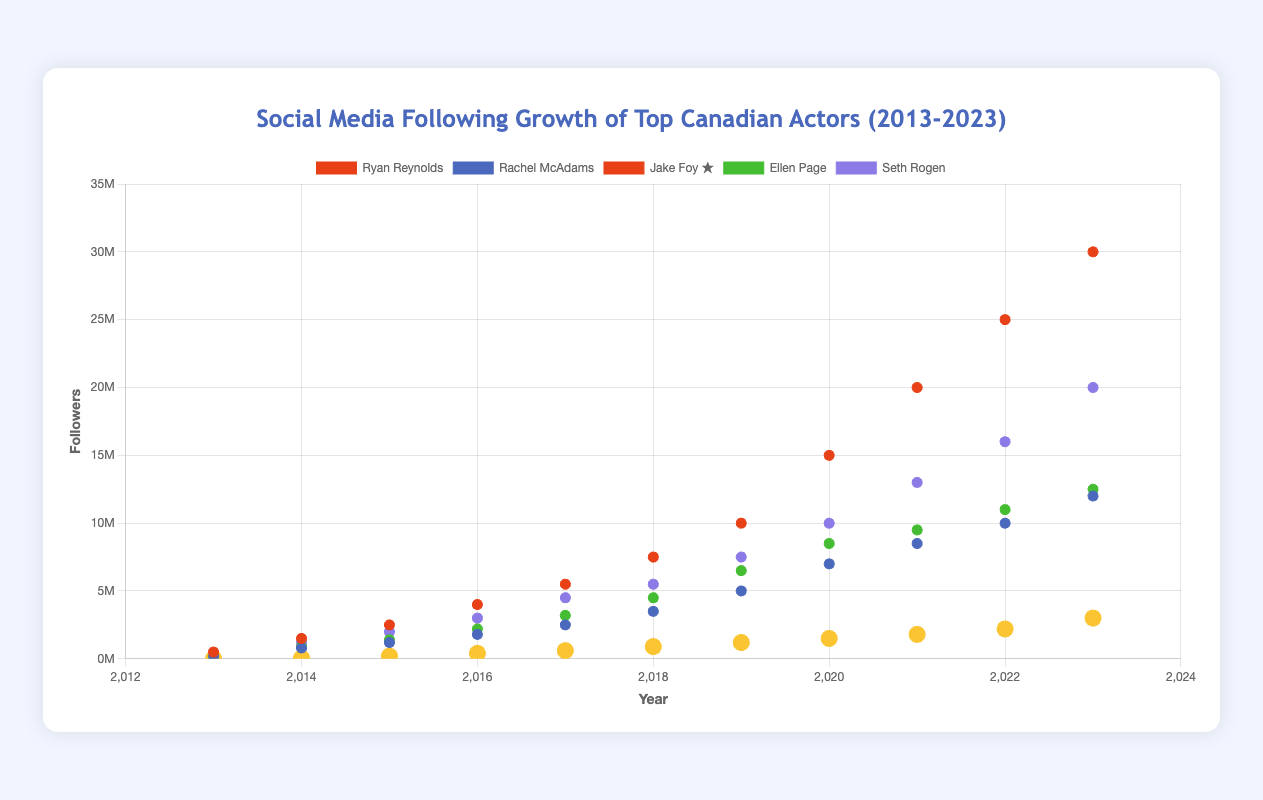what's the title of the figure? The title of the figure is prominently displayed at the top of the chart.
Answer: Social Media Following Growth of Top Canadian Actors (2013-2023) Which actor has the highest number of followers in 2023? Based on the scatter plot, Ryan Reynolds has the highest y-value (followers) at the x-value (year) 2023.
Answer: Ryan Reynolds How many actors have a following of over 10 million in 2023? Check the y-values at the x-value (year) 2023 to see which actors have more than 10 million followers.
Answer: 3 What is the trend of Jake Foy's social media following from 2013 to 2023? Jake Foy’s data points show a consistent upward trajectory in the scatter plot from 2013 to 2023.
Answer: Increasing Who had more followers in 2018, Ellen Page or Rachel McAdams? Compare the y-value of Ellen Page and Rachel McAdams at the x-value (year) 2018 in the scatter plot.
Answer: Ellen Page What is the combined social media following of Ryan Reynolds and Seth Rogen in 2020? Add the y-values of Ryan Reynolds and Seth Rogen at the x-value (year) 2020.
Answer: 25,000,000 Between which two consecutive years did Ryan Reynolds see the largest increase in followers? Identify the largest difference in followers between consecutive years by comparing y-values of Ryan Reynolds across all years.
Answer: 2019-2020 What year did Jake Foy reach 1 million followers? Look for the x-value (year) where Jake Foy's y-value (followers) crosses 1 million.
Answer: 2019 By how much did Rachel McAdams' followers increase from 2016 to 2017? Subtract the y-value of Rachel McAdams in 2016 from her y-value in 2017.
Answer: 700,000 How does the growth of Jake Foy's followers compare to the other actors? Compare the trend and slope of Jake Foy’s data points with those of the other actors across the scatter plot.
Answer: Slower growth 